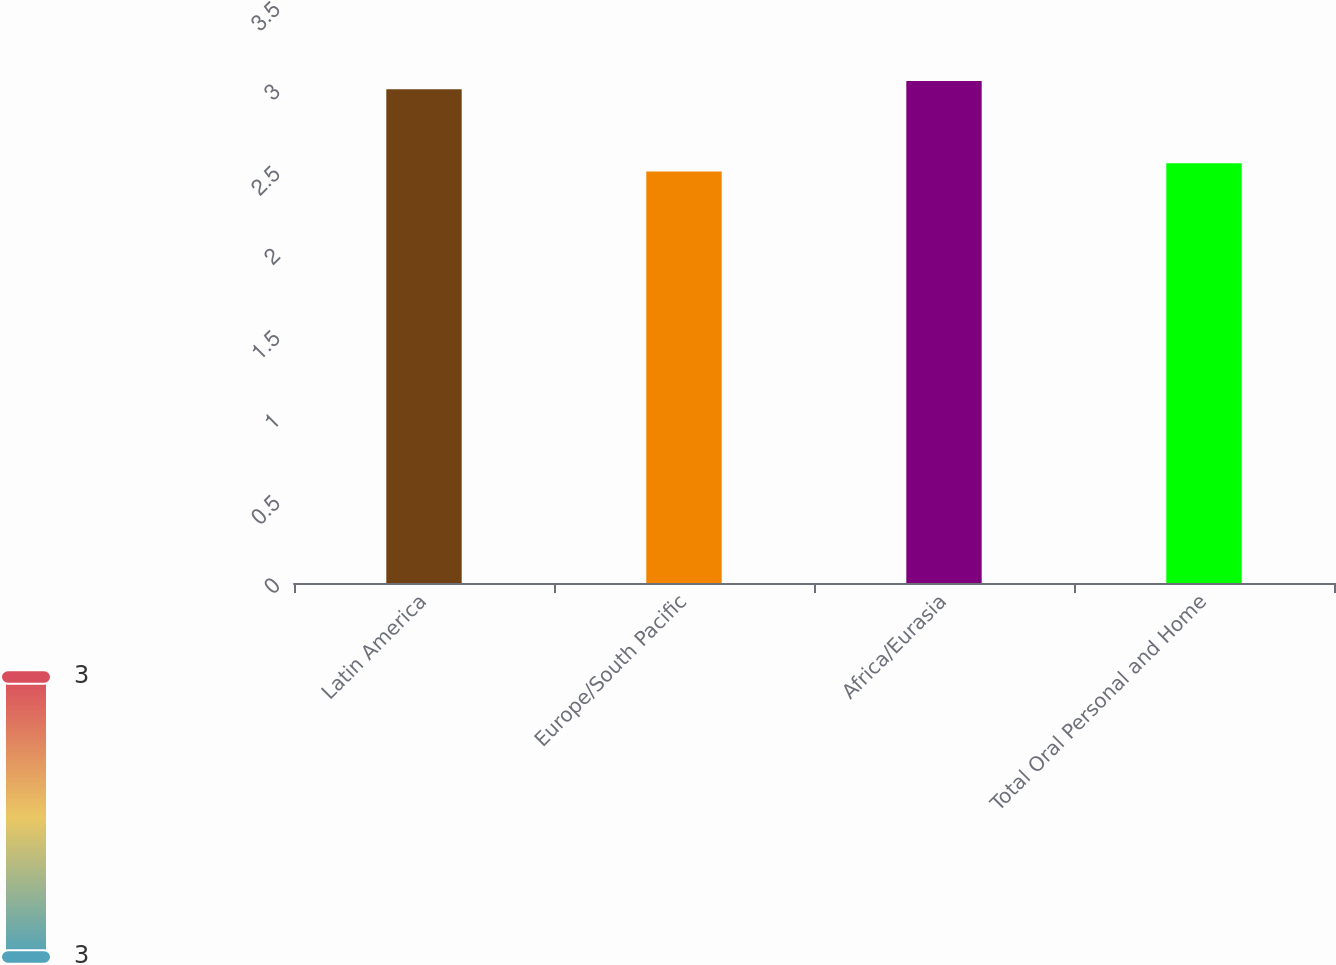<chart> <loc_0><loc_0><loc_500><loc_500><bar_chart><fcel>Latin America<fcel>Europe/South Pacific<fcel>Africa/Eurasia<fcel>Total Oral Personal and Home<nl><fcel>3<fcel>2.5<fcel>3.05<fcel>2.55<nl></chart> 